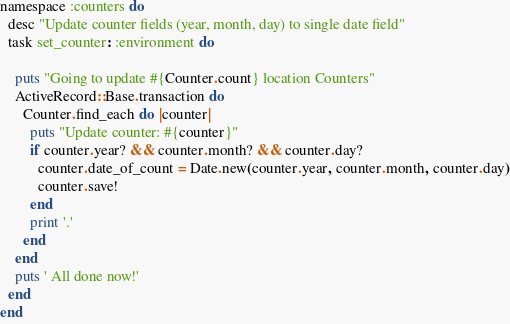<code> <loc_0><loc_0><loc_500><loc_500><_Ruby_>namespace :counters do
  desc "Update counter fields (year, month, day) to single date field"
  task set_counter: :environment do

    puts "Going to update #{Counter.count} location Counters"
    ActiveRecord::Base.transaction do
      Counter.find_each do |counter|
        puts "Update counter: #{counter}"
        if counter.year? && counter.month? && counter.day?
          counter.date_of_count = Date.new(counter.year, counter.month, counter.day)
          counter.save!
        end
        print '.'
      end
    end
    puts ' All done now!'
  end
end
</code> 